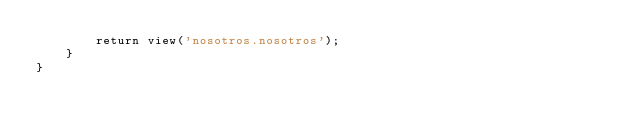Convert code to text. <code><loc_0><loc_0><loc_500><loc_500><_PHP_>        return view('nosotros.nosotros');
    }
}
</code> 